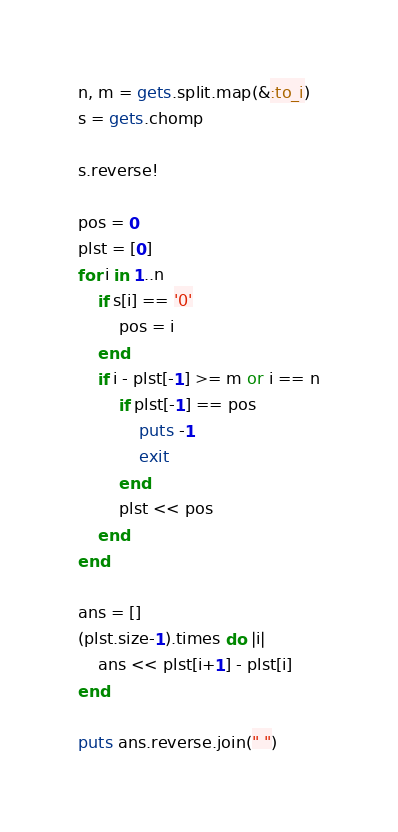Convert code to text. <code><loc_0><loc_0><loc_500><loc_500><_Ruby_>n, m = gets.split.map(&:to_i)
s = gets.chomp

s.reverse!

pos = 0
plst = [0]
for i in 1..n
    if s[i] == '0'
        pos = i
    end
    if i - plst[-1] >= m or i == n
        if plst[-1] == pos
            puts -1
            exit
        end
        plst << pos 
    end
end

ans = []
(plst.size-1).times do |i|
    ans << plst[i+1] - plst[i]
end

puts ans.reverse.join(" ")
</code> 